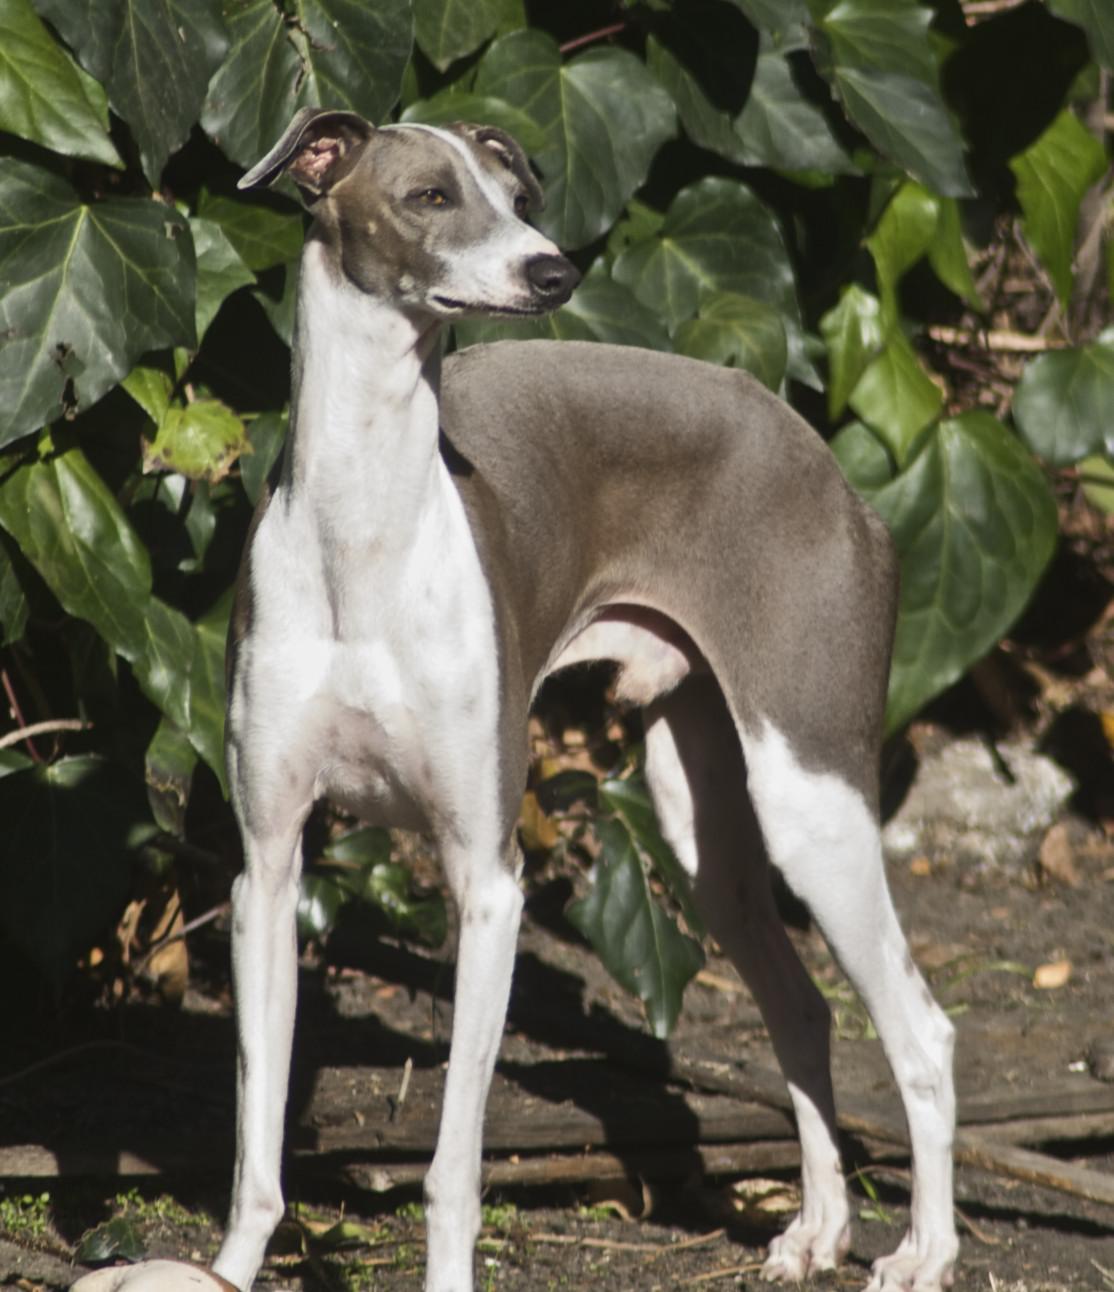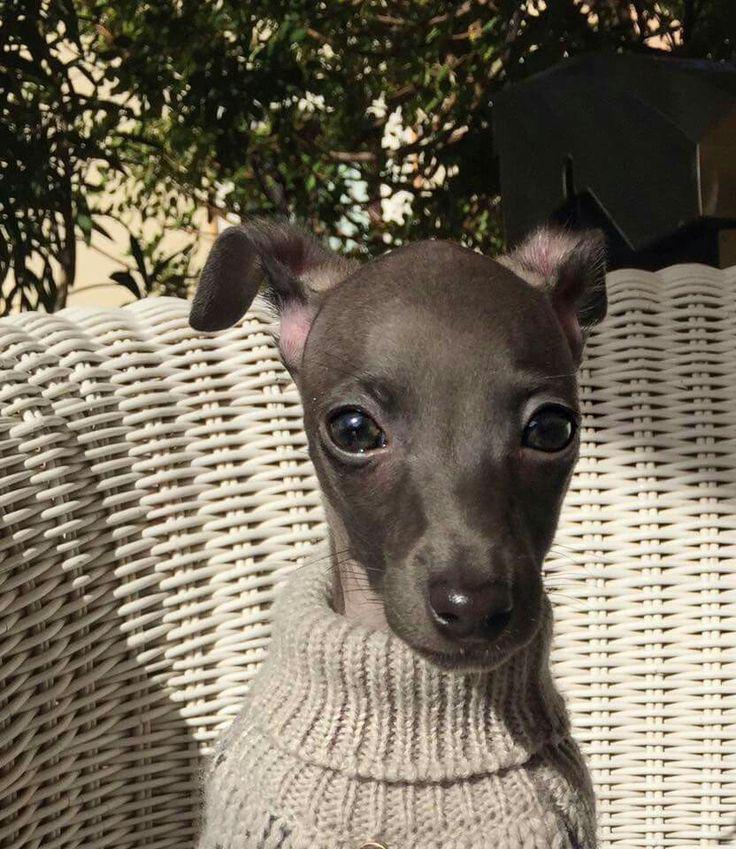The first image is the image on the left, the second image is the image on the right. Given the left and right images, does the statement "A Miniature Grehound dog is shown laying down in at least one of the images." hold true? Answer yes or no. No. The first image is the image on the left, the second image is the image on the right. Given the left and right images, does the statement "The right image shows a hound with its body touched by something beige that is soft and ribbed." hold true? Answer yes or no. Yes. 